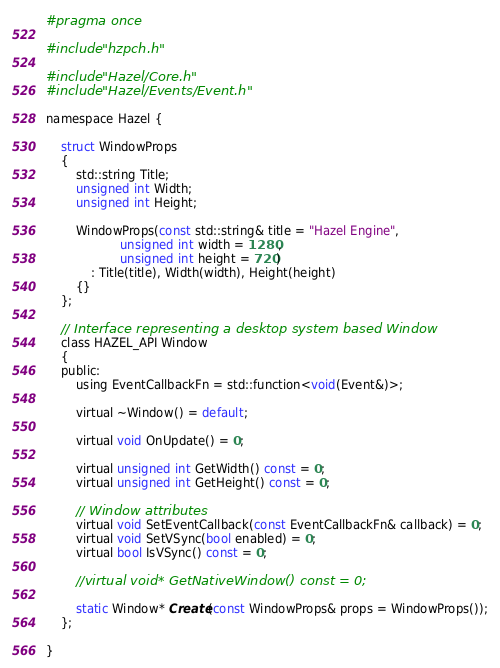Convert code to text. <code><loc_0><loc_0><loc_500><loc_500><_C_>#pragma once

#include "hzpch.h"

#include "Hazel/Core.h"
#include "Hazel/Events/Event.h"

namespace Hazel {

    struct WindowProps
    {
        std::string Title;
        unsigned int Width;
        unsigned int Height;

        WindowProps(const std::string& title = "Hazel Engine",
                    unsigned int width = 1280,
                    unsigned int height = 720)
            : Title(title), Width(width), Height(height)
        {}
    };

    // Interface representing a desktop system based Window
    class HAZEL_API Window
    {
    public:
        using EventCallbackFn = std::function<void(Event&)>;

        virtual ~Window() = default;

        virtual void OnUpdate() = 0;

        virtual unsigned int GetWidth() const = 0;
        virtual unsigned int GetHeight() const = 0;

        // Window attributes
        virtual void SetEventCallback(const EventCallbackFn& callback) = 0;
        virtual void SetVSync(bool enabled) = 0;
        virtual bool IsVSync() const = 0;

        //virtual void* GetNativeWindow() const = 0;

        static Window* Create(const WindowProps& props = WindowProps());
    };

}
</code> 